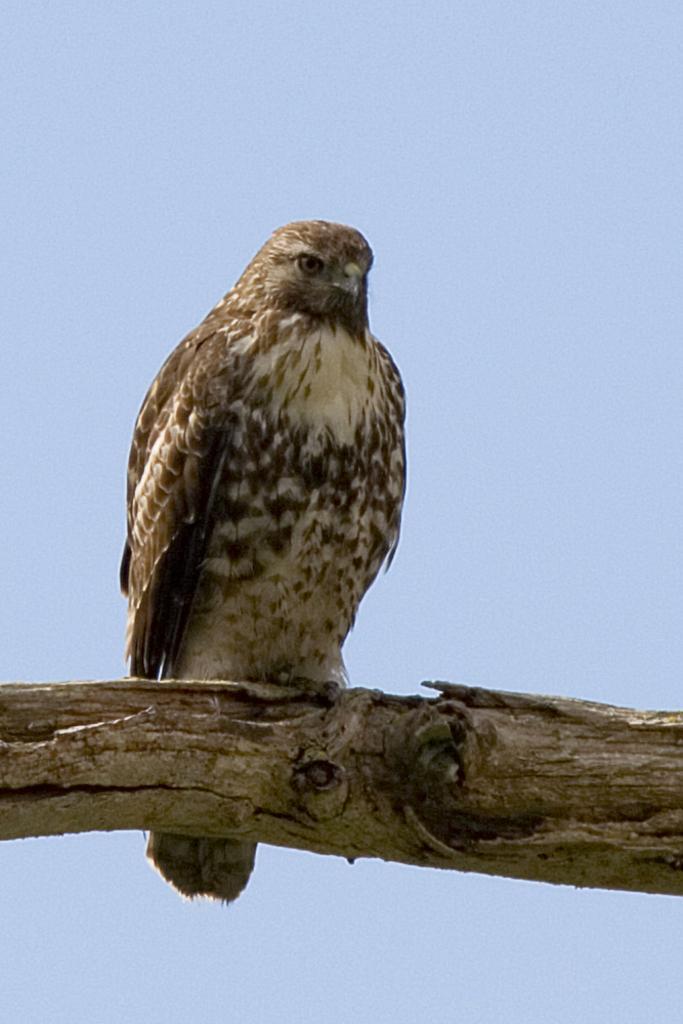How would you summarize this image in a sentence or two? In this picture I can see a eagle on the tree branch and I can see blue sky. 